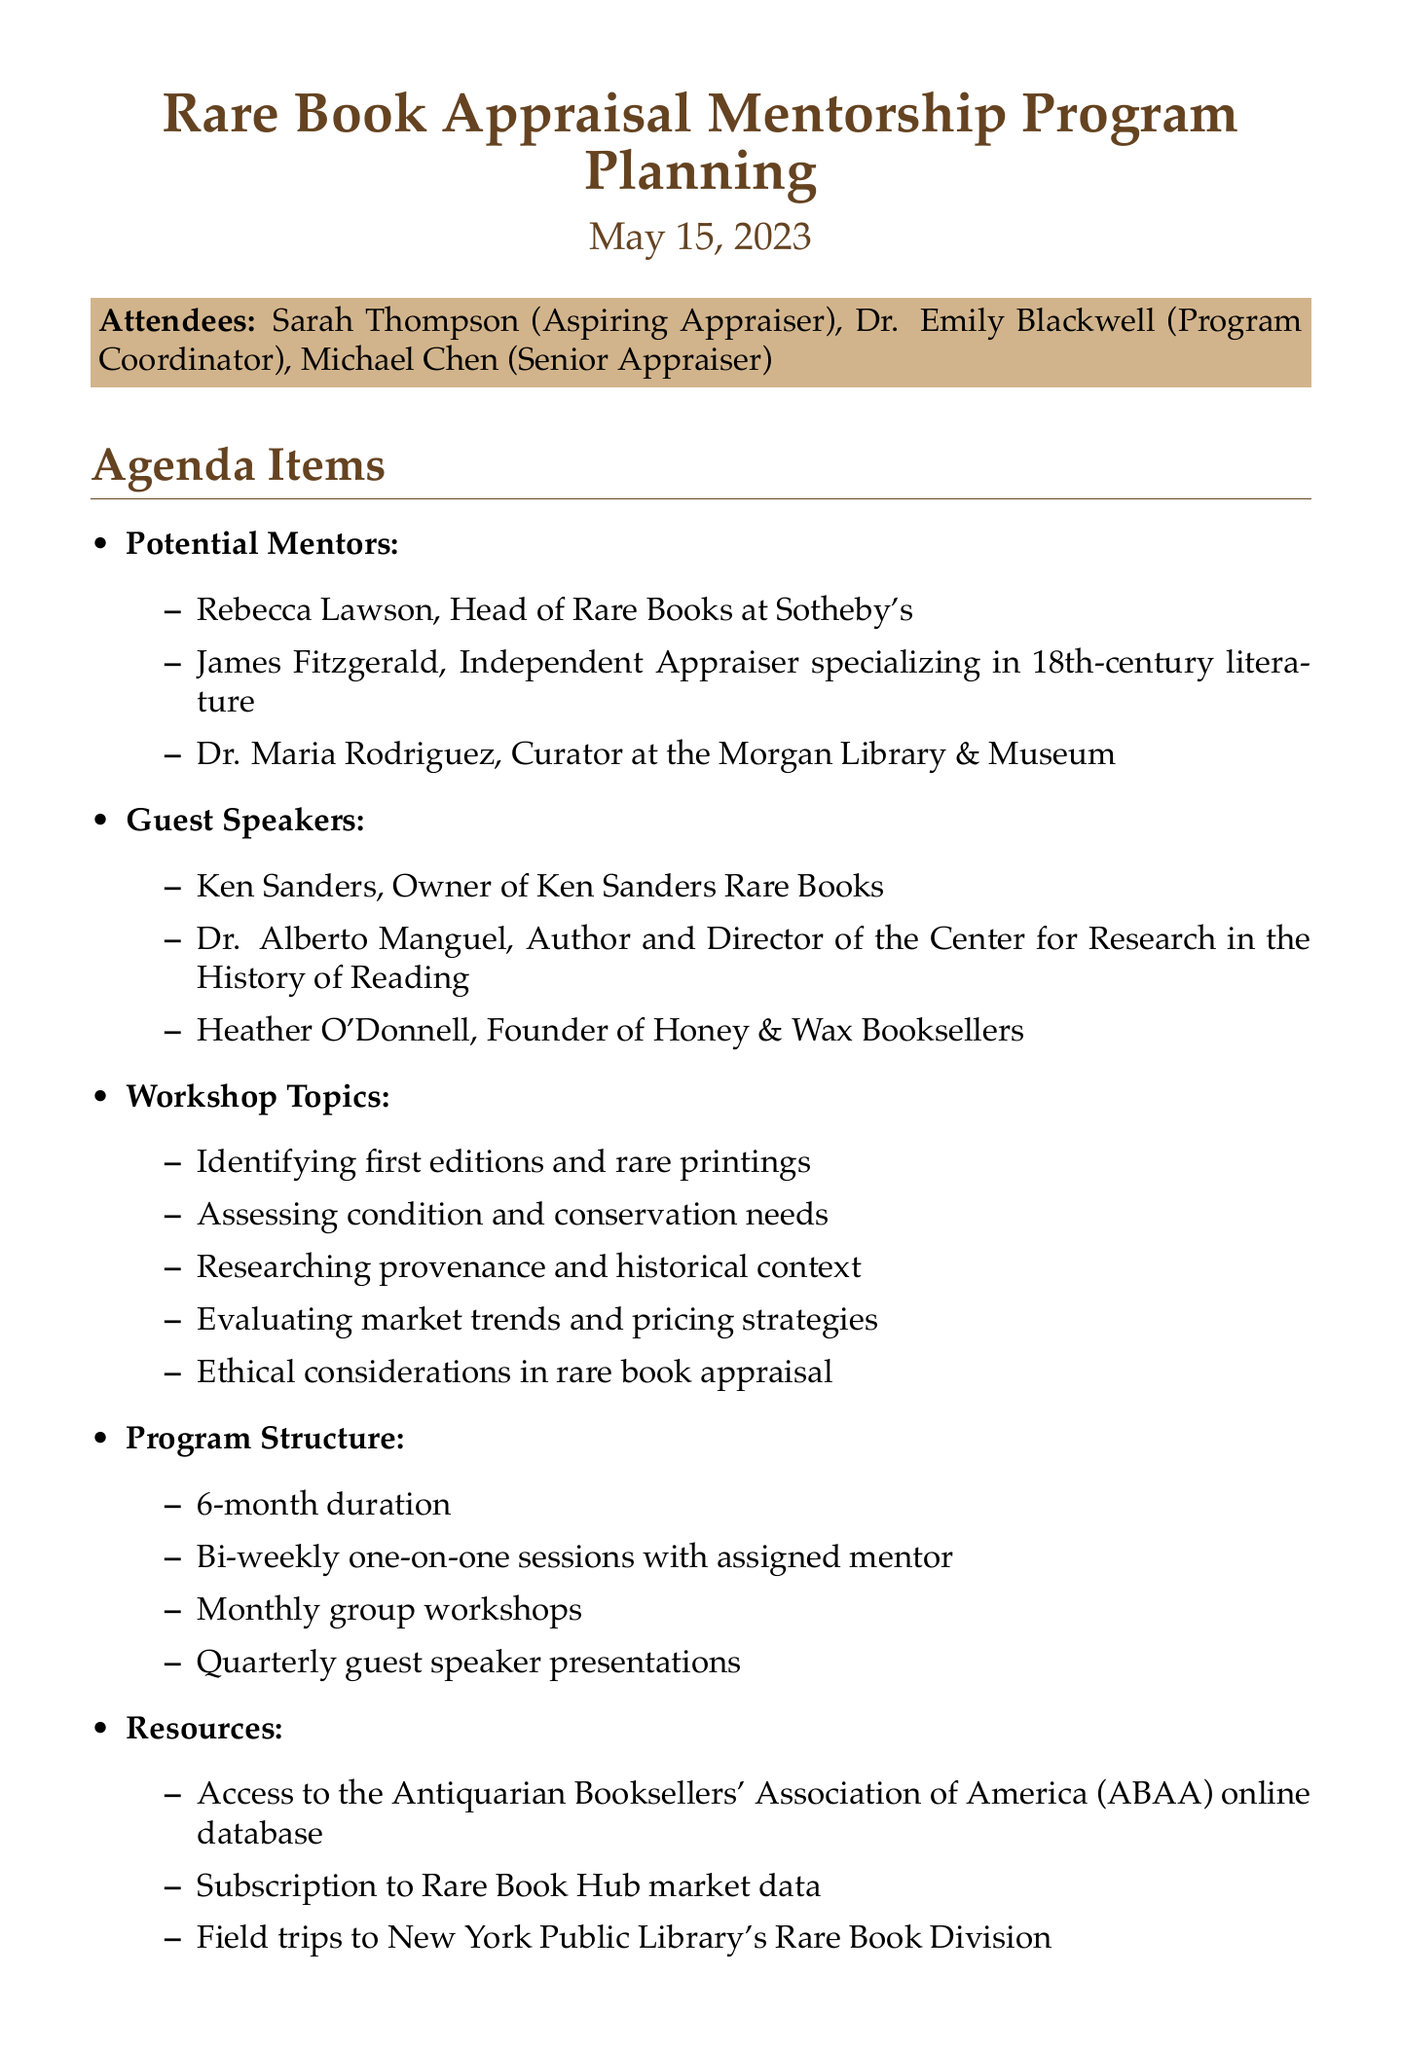What is the title of the meeting? The title of the meeting is listed at the beginning of the document as "Rare Book Appraisal Mentorship Program Planning."
Answer: Rare Book Appraisal Mentorship Program Planning Who is one of the potential mentors? The document lists several potential mentors; one of them is Rebecca Lawson.
Answer: Rebecca Lawson What is the duration of the program? The duration of the program is specified in the "Program Structure" section as 6 months.
Answer: 6 months How often will there be group workshops? The frequency of the group workshops is indicated in the "Program Structure" section as monthly.
Answer: Monthly Who will coordinate with guest speakers? The action item specifies that Michael is responsible for coordinating with guest speakers.
Answer: Michael What is one of the workshop topics? The document provides several workshop topics; one of them is "Identifying first editions and rare printings."
Answer: Identifying first editions and rare printings When is the next meeting scheduled? The date for the next meeting is mentioned within the document, which is June 1, 2023.
Answer: June 1, 2023 What type of resource is mentioned in the document? The document lists specific resources; one type mentioned is access to the Antiquarian Booksellers' Association of America (ABAA) online database.
Answer: Access to the Antiquarian Booksellers' Association of America (ABAA) online database 